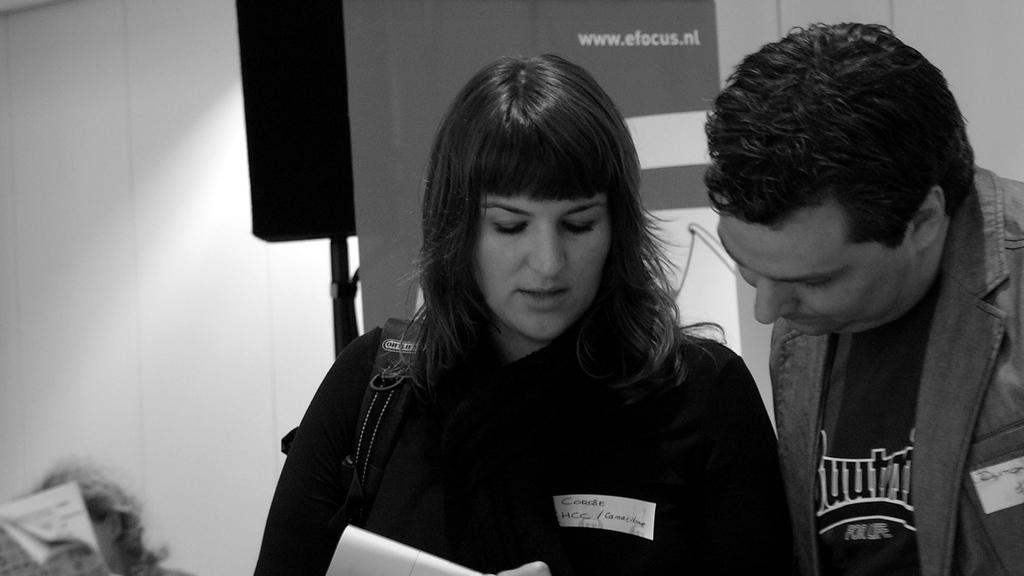<image>
Summarize the visual content of the image. A woman wearing a badge from HCC speaks with a man about some reports. 